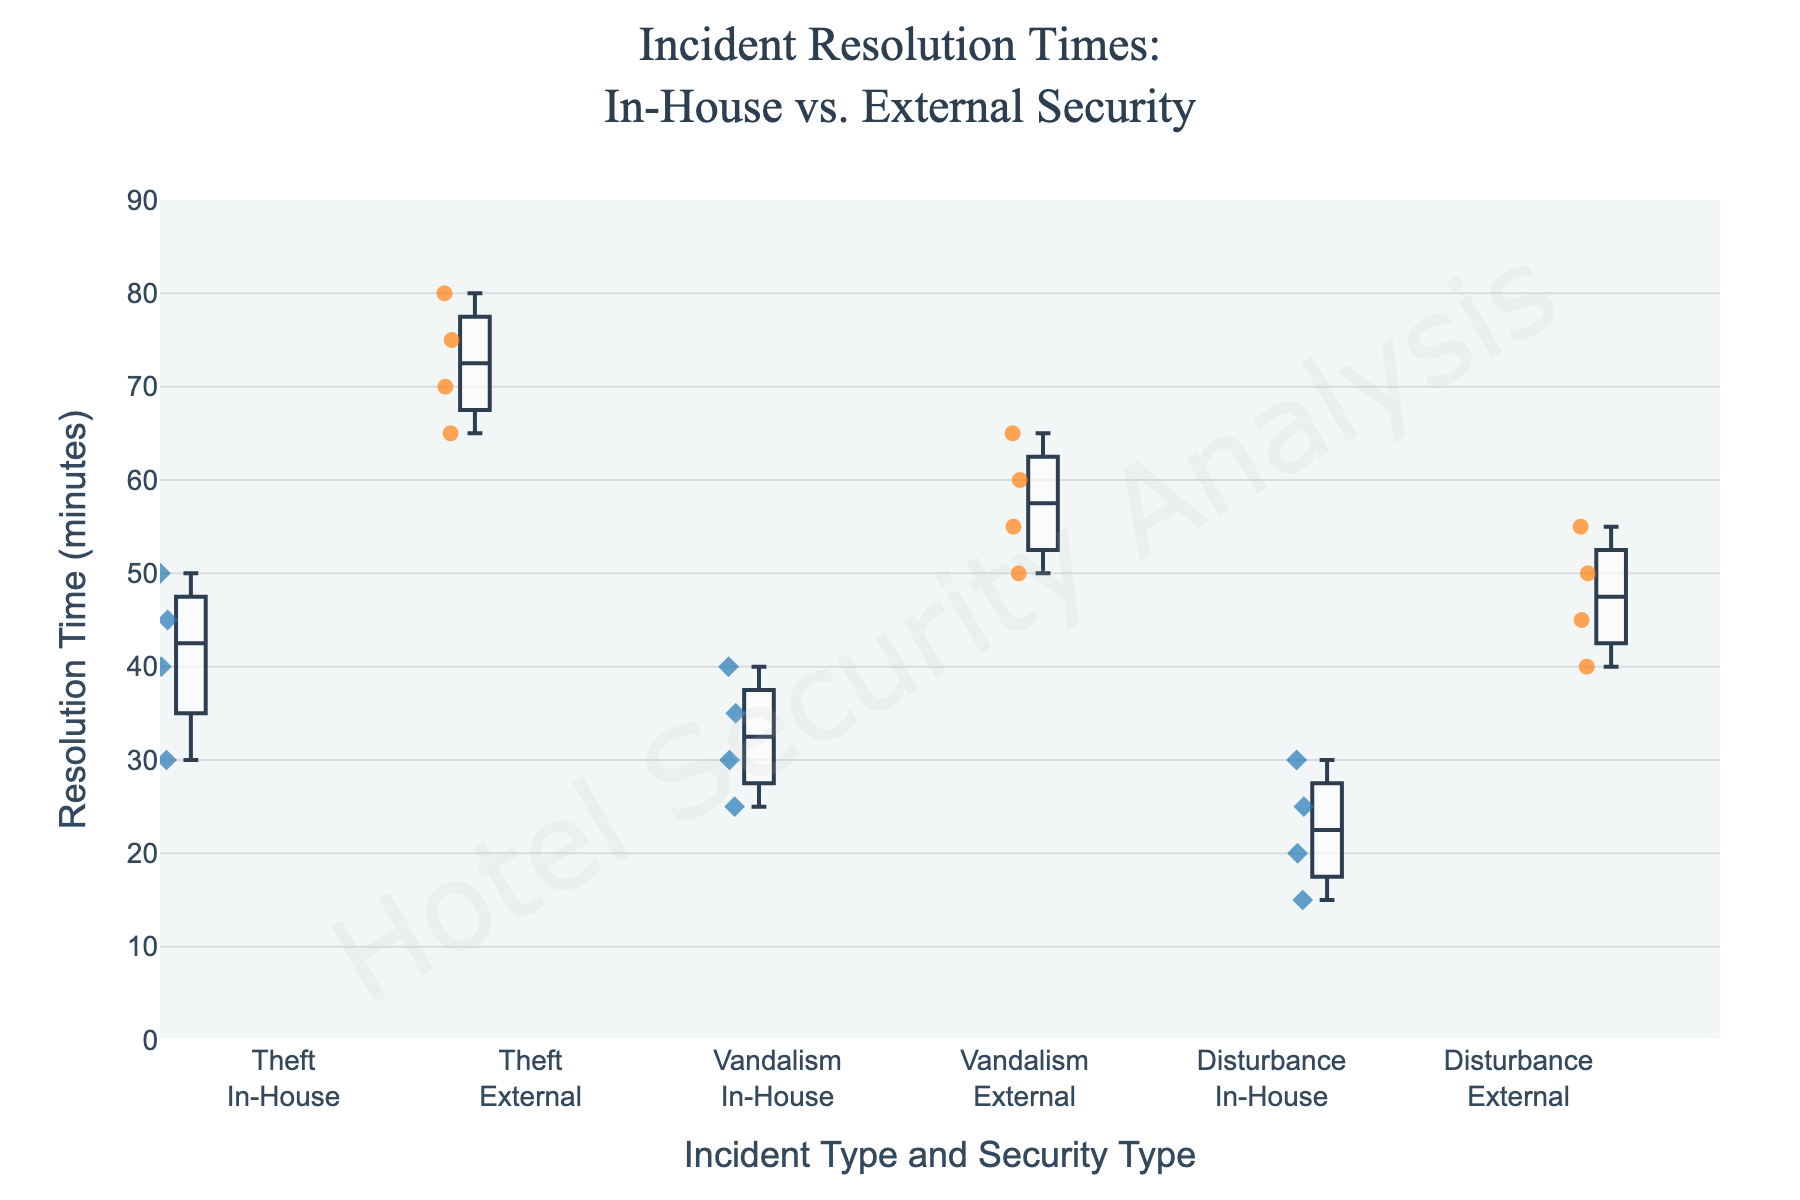Which security type primarily has the shorter resolution times? By examining the plot, we can see that the boxes representing In-House security data points are generally lower along the y-axis compared to those representing External security data points. This indicates that In-House security has shorter resolution times.
Answer: In-House What is the approximate range of resolution times for theft resolved by External security? The box plot for theft incidents resolved by External security shows data points ranging from about 65 to 80 minutes.
Answer: 65 to 80 minutes Which incident type shows the smallest difference in resolution times between In-House and External security? By comparing the heights of the boxes across incident types, disturbance incidents show the smallest difference in resolution times between In-House and External security. The resolution times of disturbances for In-House security range between 15 to 30 minutes, and those for External security range between 40 to 55 minutes.
Answer: Disturbance What is the median resolution time for vandalism incidents resolved by In-House security? The median can be found at the line inside the box for vandalism incidents resolved by In-House security. This value appears to be around 32.5 minutes.
Answer: 32.5 minutes How many types of incidents are included in the plot? By observing the x-axis labels, three incident types can be noted: Theft, Vandalism, and Disturbance.
Answer: 3 Which security type, on average, takes longer to resolve incidents? The overall trend in this plot shows that the boxes and whiskers for External security are positioned higher on the y-axis than those for In-House security across all incident types, indicating longer resolution times.
Answer: External What is the maximum resolution time for disturbances resolved by In-House security? The upper whisker for disturbances resolved by In-House security points to a maximum resolution time of about 30 minutes.
Answer: 30 minutes What's the interquartile range (IQR) for theft incidents resolved by In-House security? The IQR can be calculated by subtracting the lower quartile (25th percentile) from the upper quartile (75th percentile). For theft incidents resolved by In-House security, the lower quartile is around 30 minutes and the upper quartile is around 45 minutes, so the IQR is 45 - 30 = 15 minutes.
Answer: 15 minutes Is there any overlap in resolution times between In-House and External security within the same incident type? Observing the box plots within each incident type shows no overlap between the resolution times of In-House and External security for theft, vandalism, or disturbance incidents. Every pair of box plots for these incident types is distinct without intersecting each other.
Answer: No 